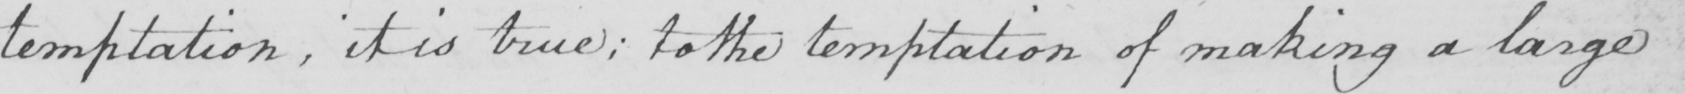What is written in this line of handwriting? temptation , it is true ; to the temptation of making a large 